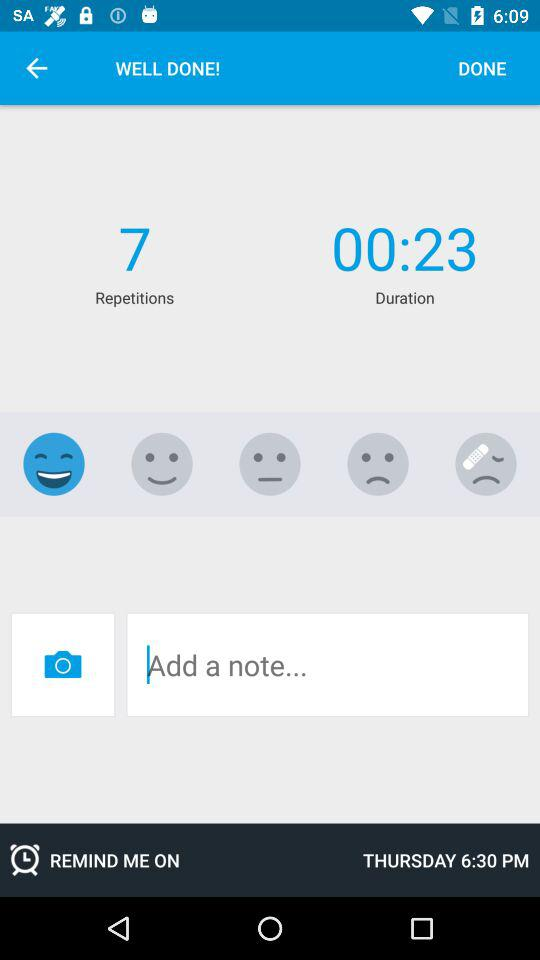What is the number of repetitions? The number of repetitions is 7. 